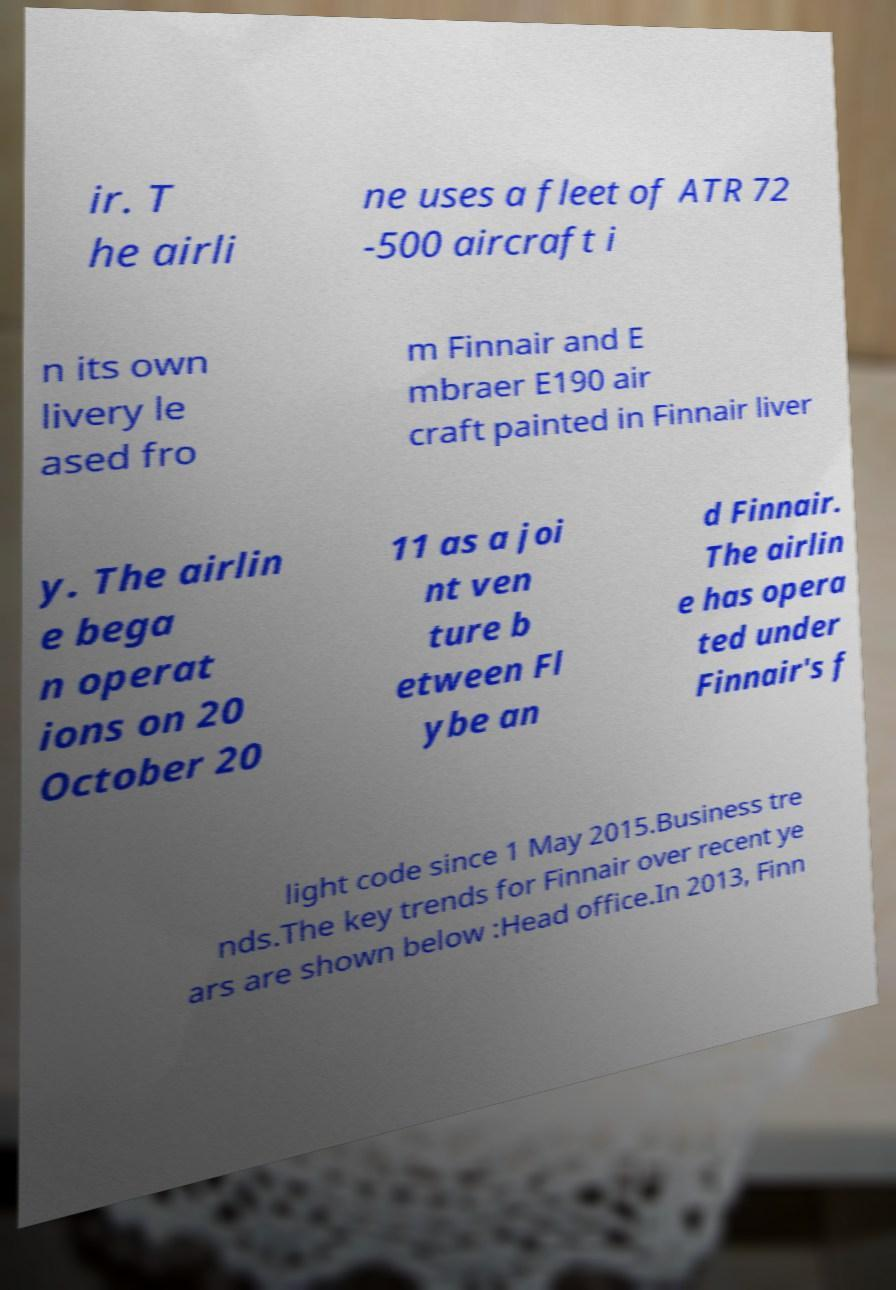I need the written content from this picture converted into text. Can you do that? ir. T he airli ne uses a fleet of ATR 72 -500 aircraft i n its own livery le ased fro m Finnair and E mbraer E190 air craft painted in Finnair liver y. The airlin e bega n operat ions on 20 October 20 11 as a joi nt ven ture b etween Fl ybe an d Finnair. The airlin e has opera ted under Finnair's f light code since 1 May 2015.Business tre nds.The key trends for Finnair over recent ye ars are shown below :Head office.In 2013, Finn 